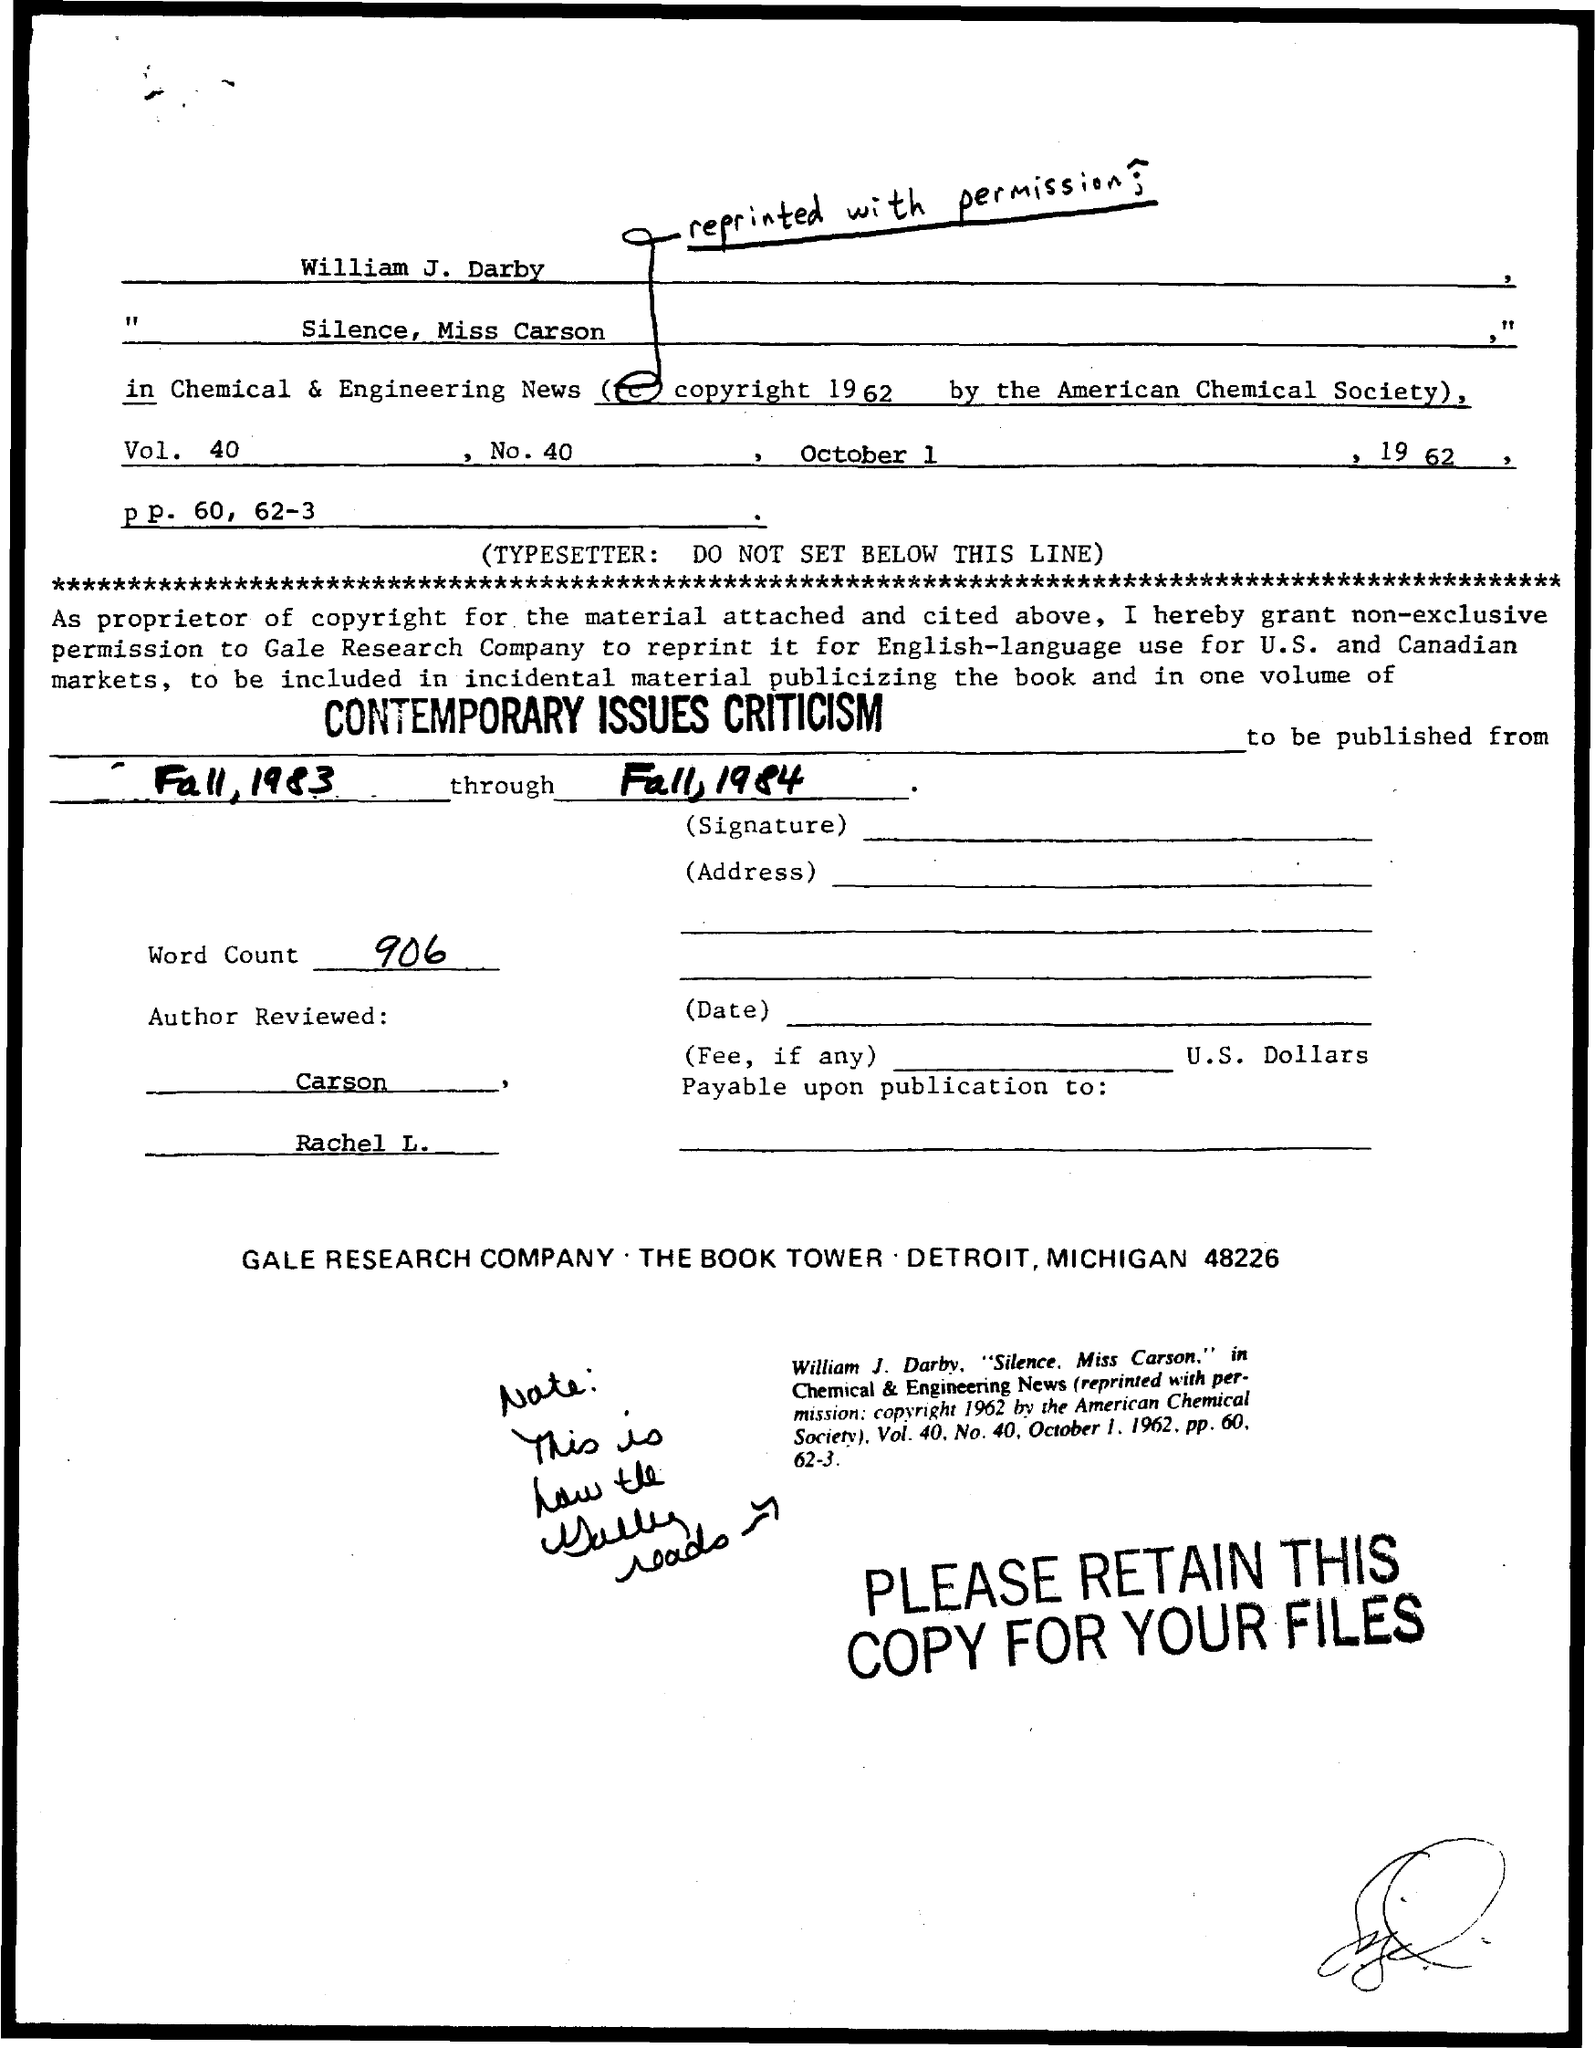List a handful of essential elements in this visual. The American Chemical Society held the copyright for a society known for its expertise in chemical matters. The Gale Research Company is authorized to reprint this material. A total of 906 words were counted. 